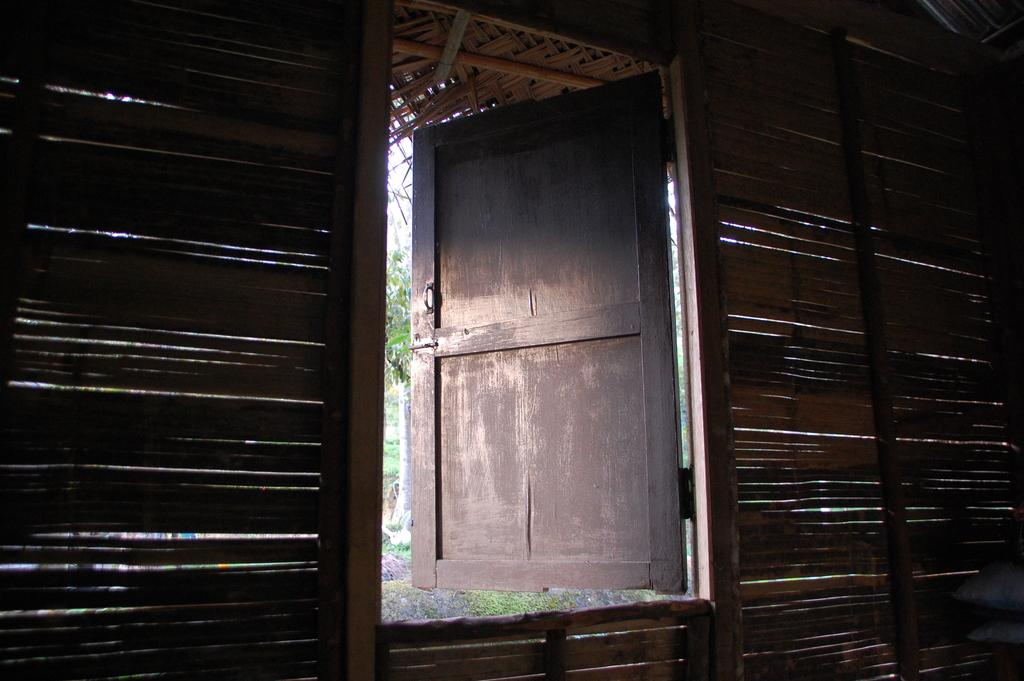What type of wall is visible in the foreground of the picture? There is a wooden wall in the foreground of the picture. What feature is present in the wooden wall? There is a door in the wooden wall. What can be seen outside the door? Plants and grass are visible outside the door. How many dinosaurs can be seen grazing in the grass outside the door? There are no dinosaurs present in the image; it features a wooden wall, a door, plants, and grass. 